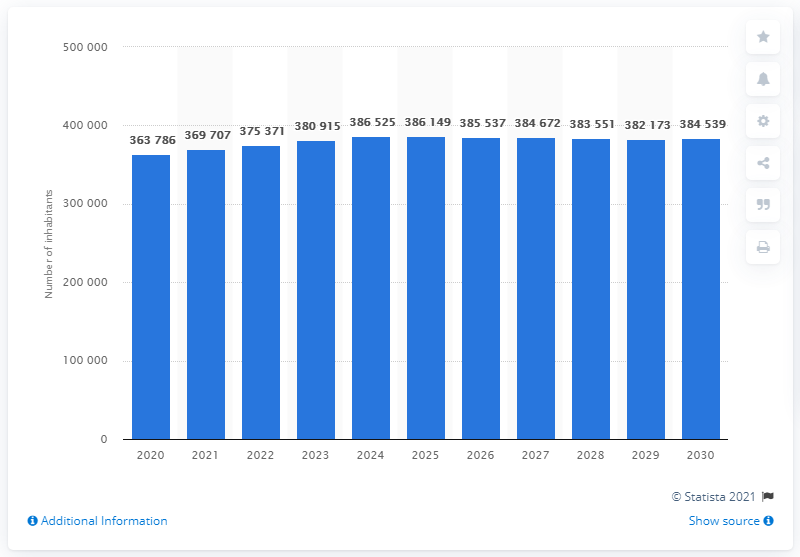Specify some key components in this picture. It was expected that by the year 2029, Iceland would have a slight population of men over women. The estimated population of Iceland by 2030 is projected to be 384,539 individuals. 